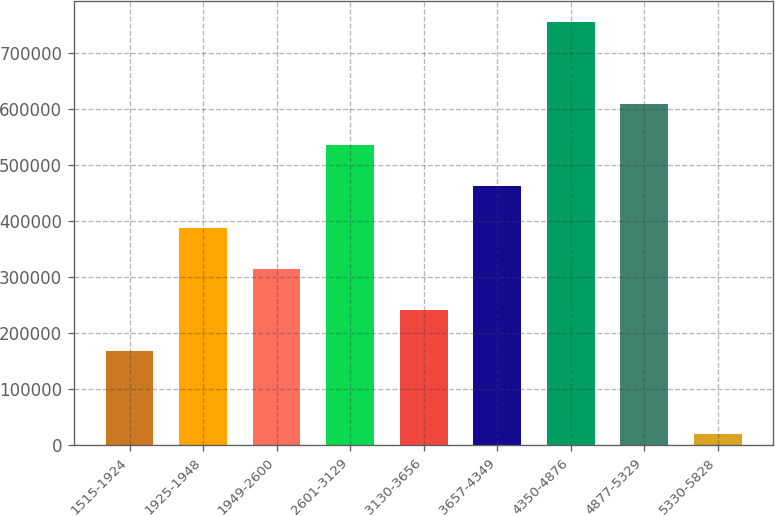Convert chart to OTSL. <chart><loc_0><loc_0><loc_500><loc_500><bar_chart><fcel>1515-1924<fcel>1925-1948<fcel>1949-2600<fcel>2601-3129<fcel>3130-3656<fcel>3657-4349<fcel>4350-4876<fcel>4877-5329<fcel>5330-5828<nl><fcel>167438<fcel>387881<fcel>314400<fcel>534842<fcel>240919<fcel>461362<fcel>754387<fcel>608323<fcel>19578<nl></chart> 